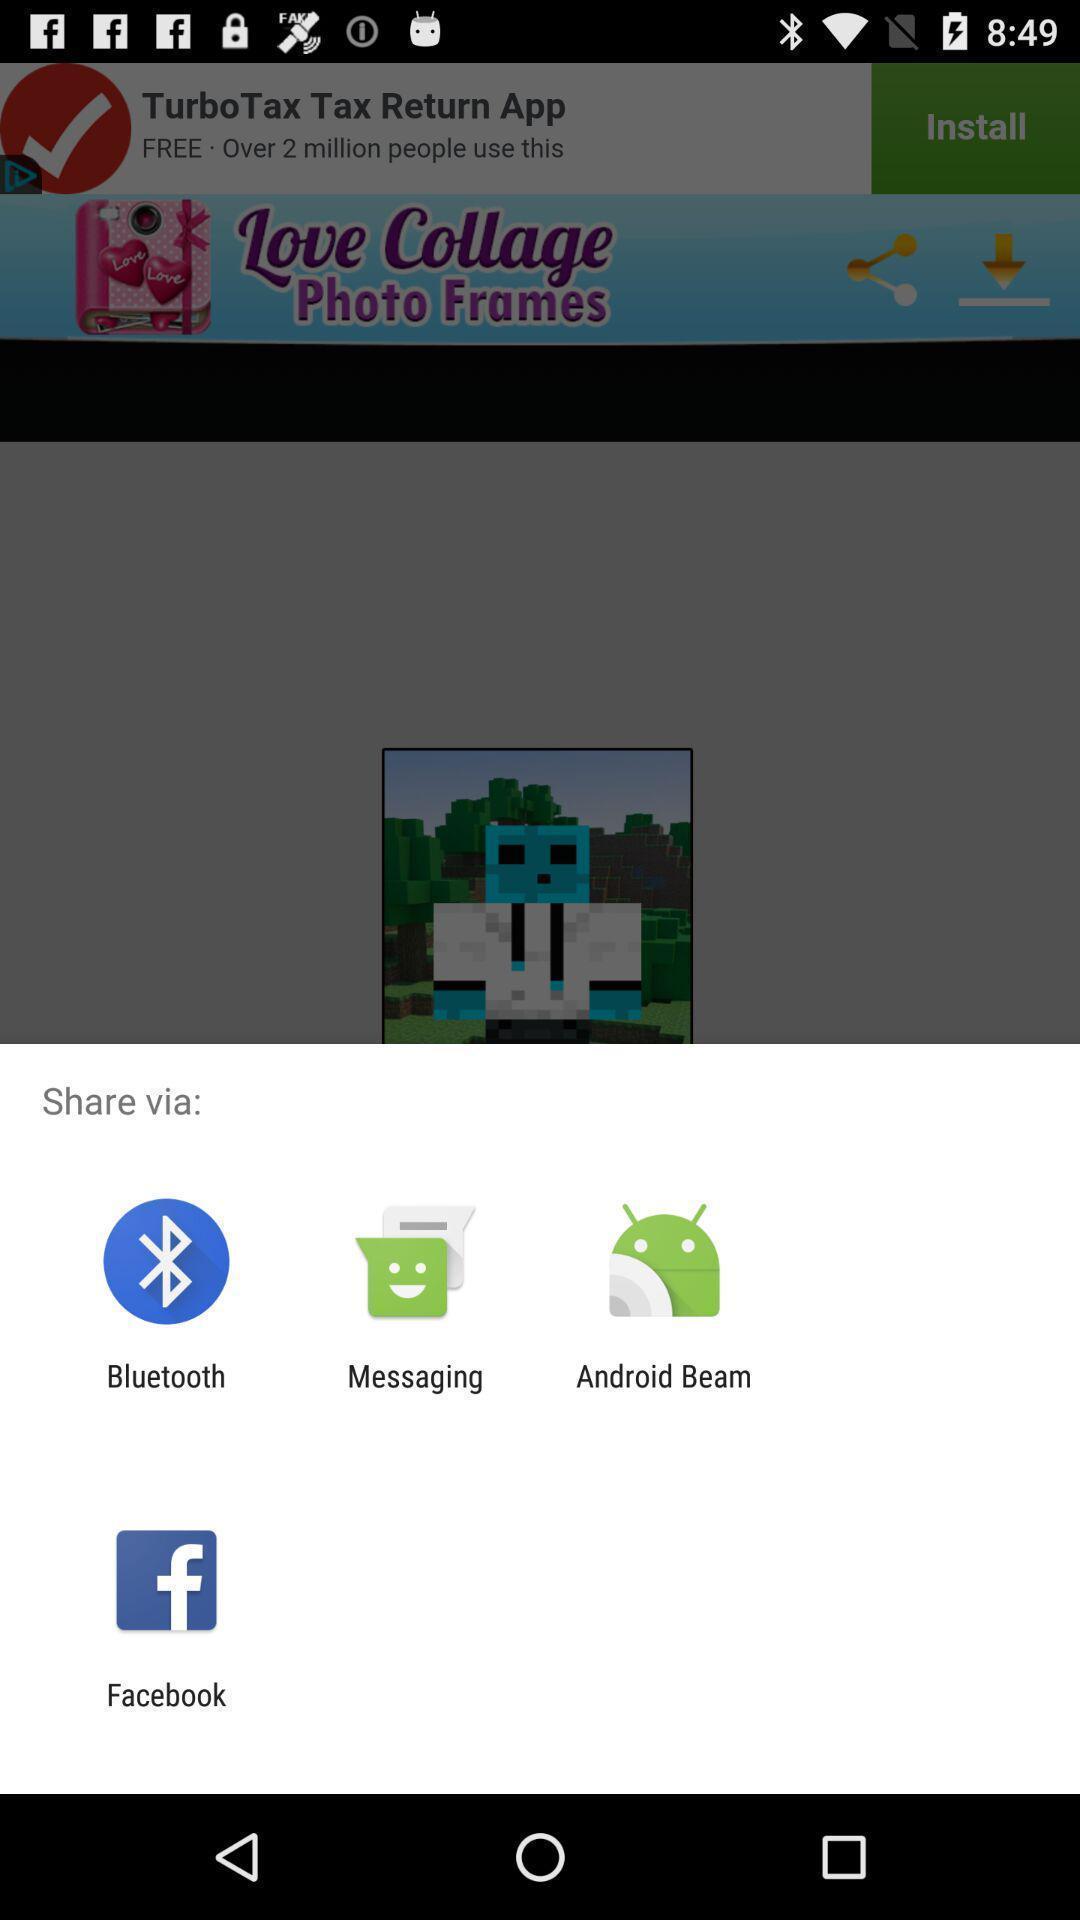What details can you identify in this image? Screen showing various applications to share. 